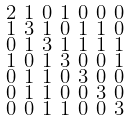Convert formula to latex. <formula><loc_0><loc_0><loc_500><loc_500>\begin{smallmatrix} 2 & 1 & 0 & 1 & 0 & 0 & 0 \\ 1 & 3 & 1 & 0 & 1 & 1 & 0 \\ 0 & 1 & 3 & 1 & 1 & 1 & 1 \\ 1 & 0 & 1 & 3 & 0 & 0 & 1 \\ 0 & 1 & 1 & 0 & 3 & 0 & 0 \\ 0 & 1 & 1 & 0 & 0 & 3 & 0 \\ 0 & 0 & 1 & 1 & 0 & 0 & 3 \end{smallmatrix}</formula> 